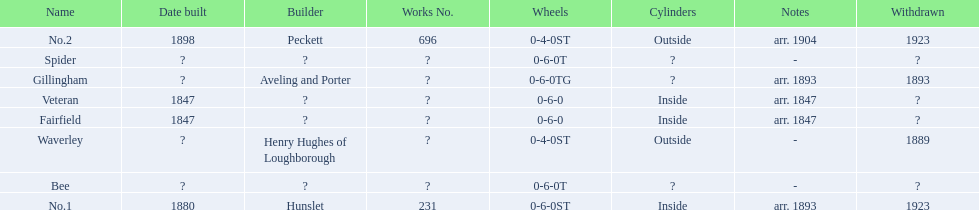What name is listed after spider? Gillingham. 